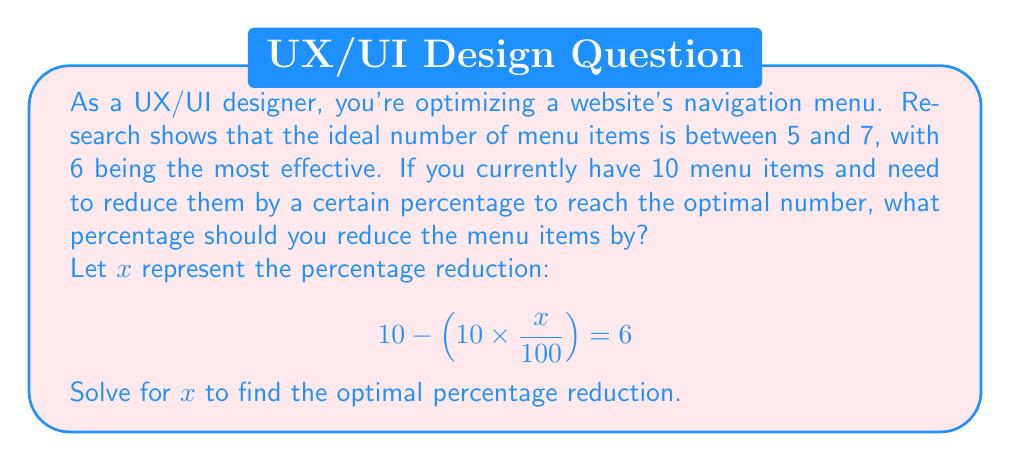Can you answer this question? Let's solve this step-by-step:

1) We start with the equation:
   $$10 - (10 \times \frac{x}{100}) = 6$$

2) Simplify the left side of the equation:
   $$10 - 0.1x = 6$$

3) Subtract 10 from both sides:
   $$-0.1x = -4$$

4) Divide both sides by -0.1:
   $$x = 40$$

5) Interpret the result:
   A 40% reduction in menu items will reduce the count from 10 to 6.

To verify:
$$10 - (10 \times \frac{40}{100}) = 10 - 4 = 6$$

This aligns with the research showing that 6 menu items is the most effective number for navigation menus.
Answer: $x = 40$% 